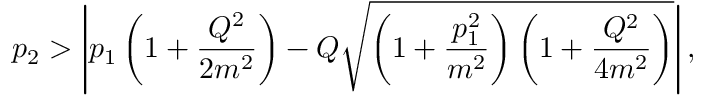Convert formula to latex. <formula><loc_0><loc_0><loc_500><loc_500>p _ { 2 } > \left | p _ { 1 } \left ( 1 + \frac { Q ^ { 2 } } { 2 m ^ { 2 } } \right ) - Q \sqrt { \left ( 1 + \frac { p _ { 1 } ^ { 2 } } { m ^ { 2 } } \right ) \left ( 1 + \frac { Q ^ { 2 } } { 4 m ^ { 2 } } \right ) } \right | ,</formula> 